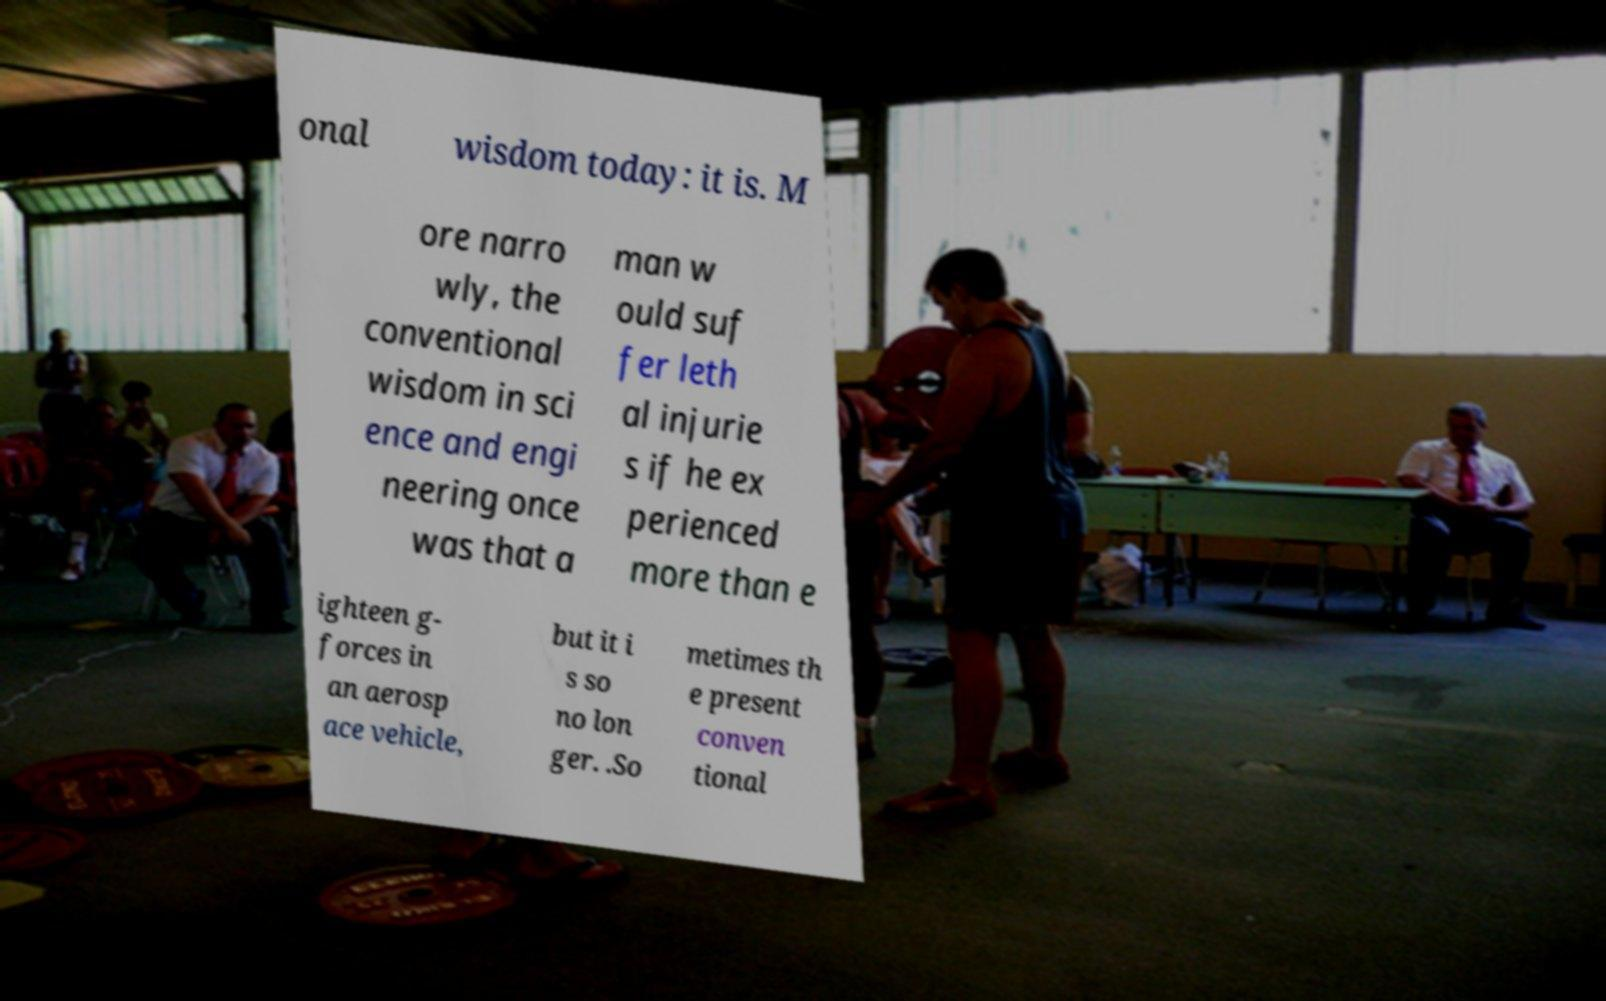There's text embedded in this image that I need extracted. Can you transcribe it verbatim? onal wisdom today: it is. M ore narro wly, the conventional wisdom in sci ence and engi neering once was that a man w ould suf fer leth al injurie s if he ex perienced more than e ighteen g- forces in an aerosp ace vehicle, but it i s so no lon ger. .So metimes th e present conven tional 